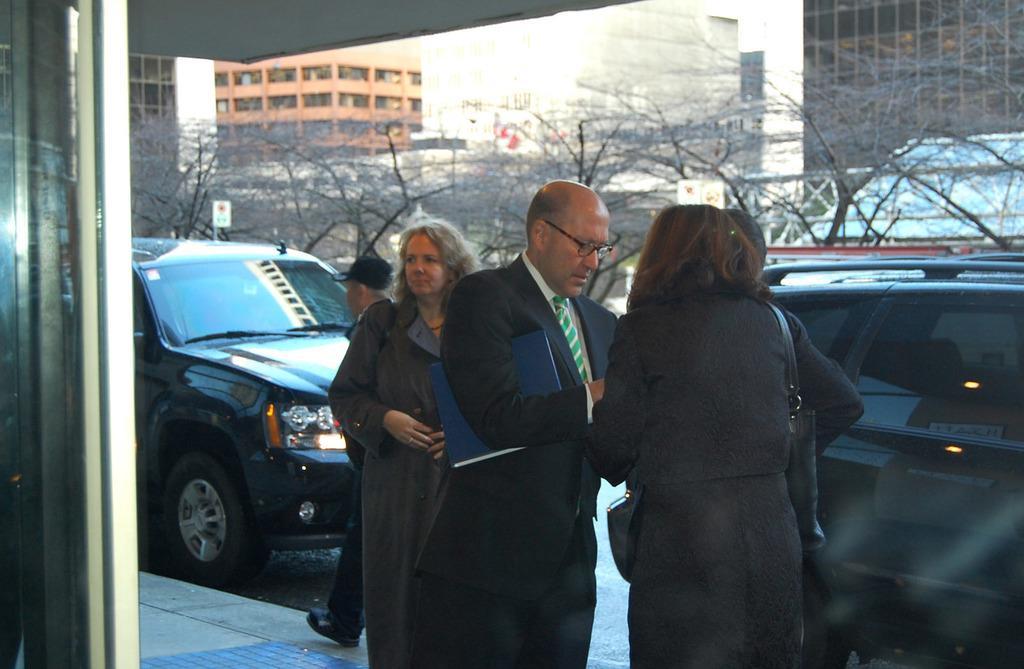Describe this image in one or two sentences. In this image I can see group of people standing. In front the person is wearing black blazer, white shirt and green color tie. Background I can see few vehicles, dried trees, buildings in white, gray and brown color and the sky is in white color. 